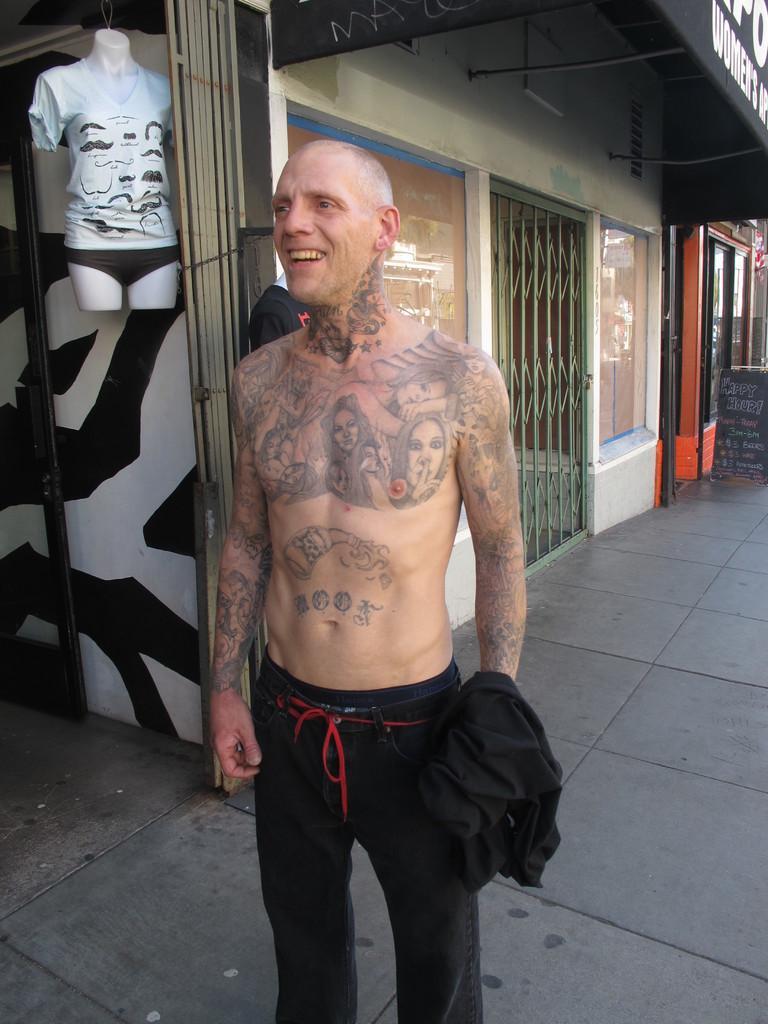Please provide a concise description of this image. In this image, we can see a person wearing clothes and standing in front of the building. There is a display model in the top left of the image. 